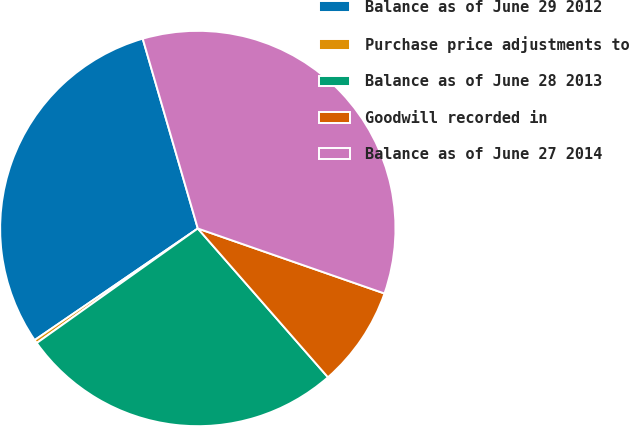Convert chart. <chart><loc_0><loc_0><loc_500><loc_500><pie_chart><fcel>Balance as of June 29 2012<fcel>Purchase price adjustments to<fcel>Balance as of June 28 2013<fcel>Goodwill recorded in<fcel>Balance as of June 27 2014<nl><fcel>30.05%<fcel>0.29%<fcel>26.6%<fcel>8.23%<fcel>34.83%<nl></chart> 